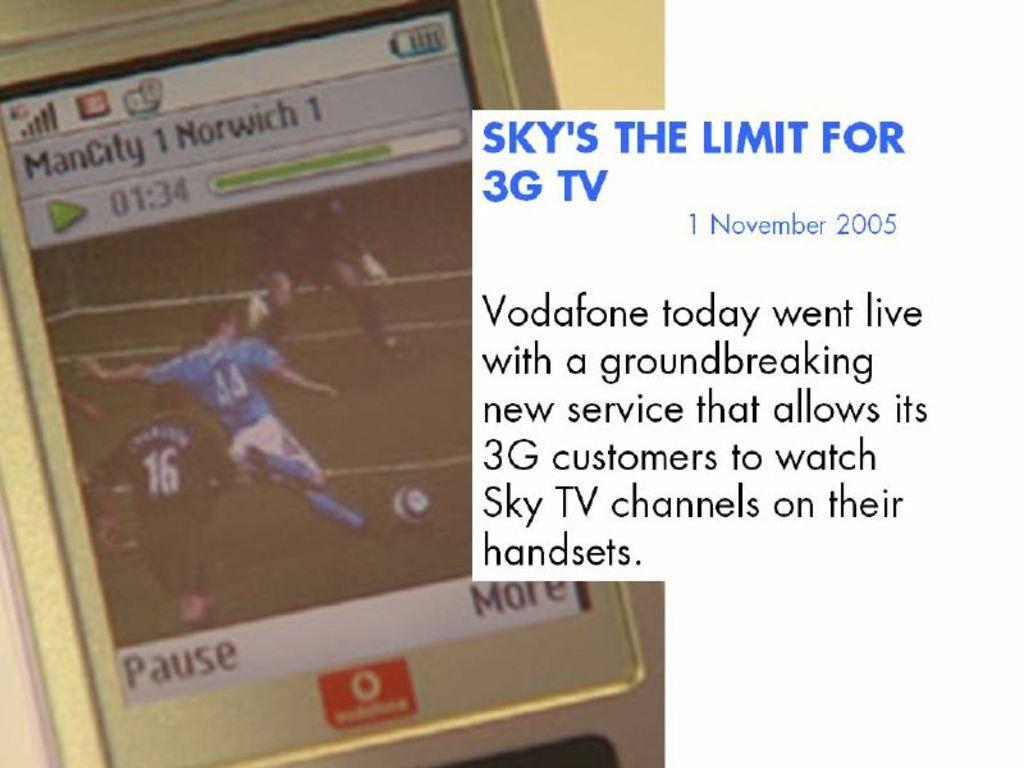<image>
Create a compact narrative representing the image presented. An advertisement for Vodaphone's new 3G television technology. 